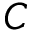<formula> <loc_0><loc_0><loc_500><loc_500>C</formula> 